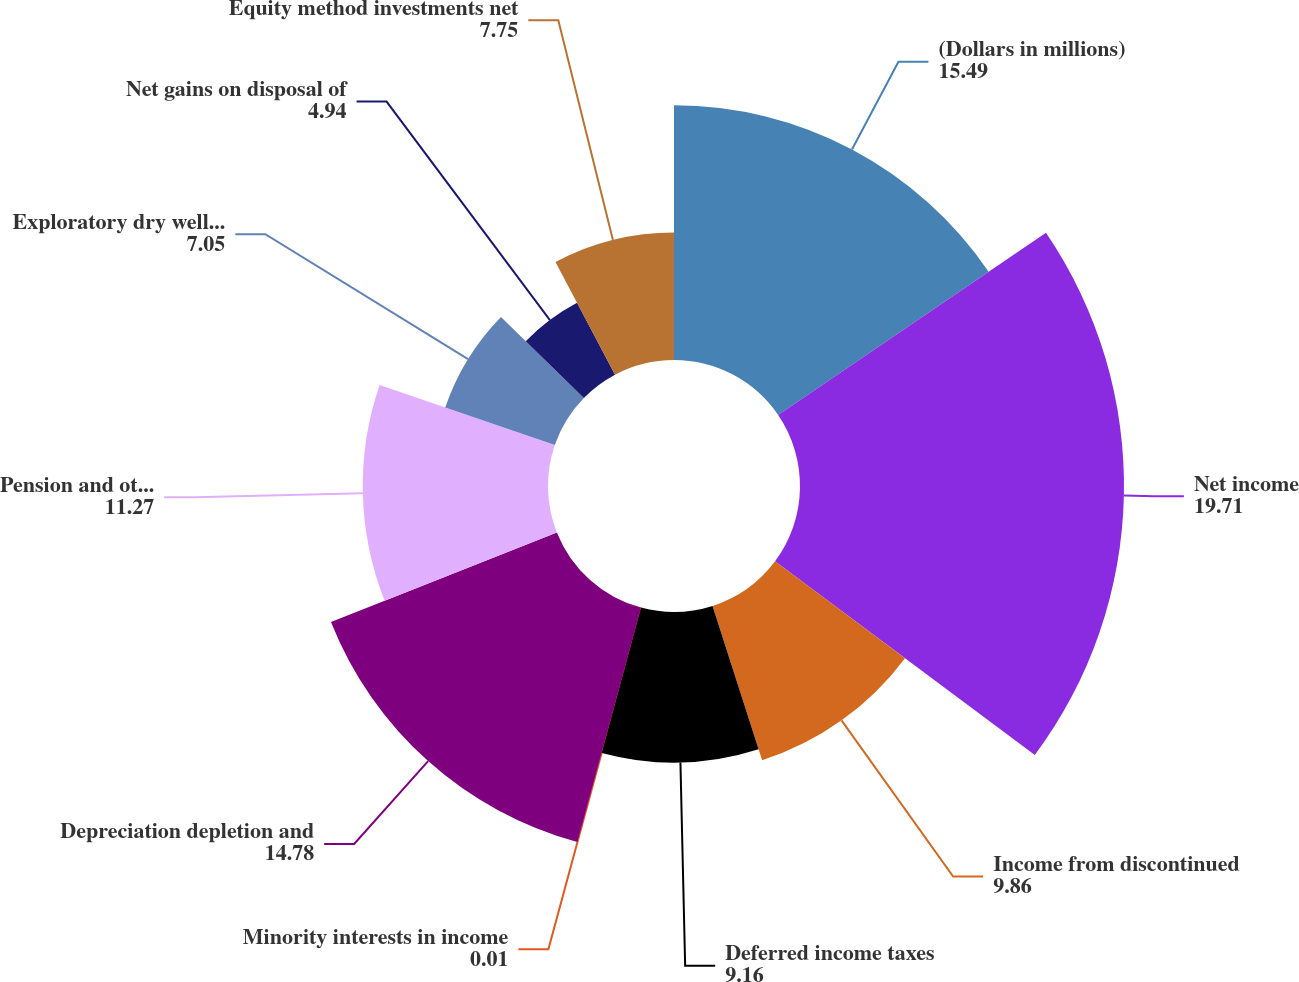Convert chart. <chart><loc_0><loc_0><loc_500><loc_500><pie_chart><fcel>(Dollars in millions)<fcel>Net income<fcel>Income from discontinued<fcel>Deferred income taxes<fcel>Minority interests in income<fcel>Depreciation depletion and<fcel>Pension and other<fcel>Exploratory dry well costs and<fcel>Net gains on disposal of<fcel>Equity method investments net<nl><fcel>15.49%<fcel>19.71%<fcel>9.86%<fcel>9.16%<fcel>0.01%<fcel>14.78%<fcel>11.27%<fcel>7.05%<fcel>4.94%<fcel>7.75%<nl></chart> 